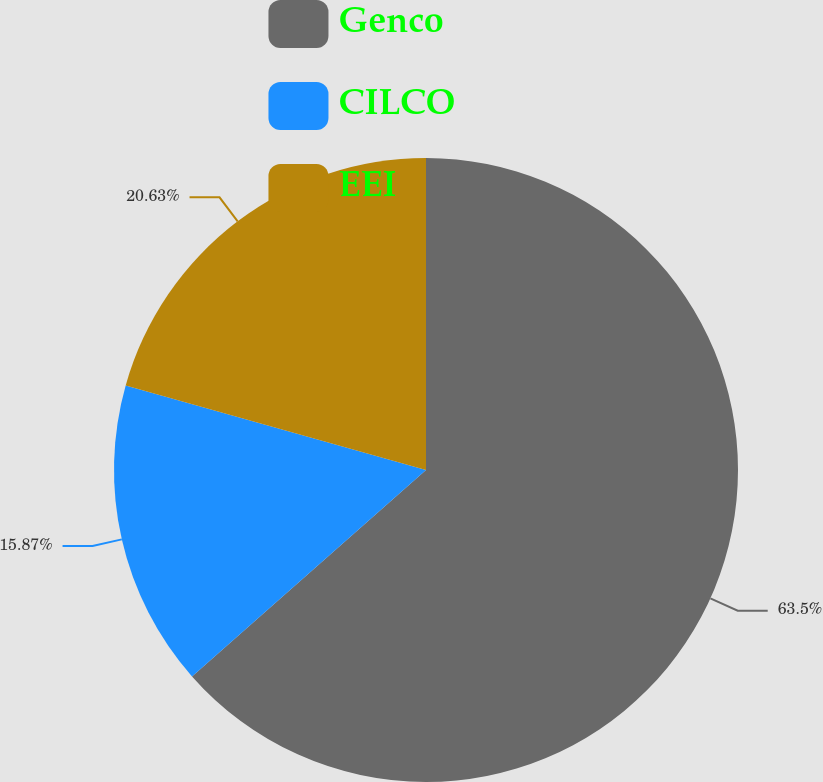Convert chart to OTSL. <chart><loc_0><loc_0><loc_500><loc_500><pie_chart><fcel>Genco<fcel>CILCO<fcel>EEI<nl><fcel>63.49%<fcel>15.87%<fcel>20.63%<nl></chart> 